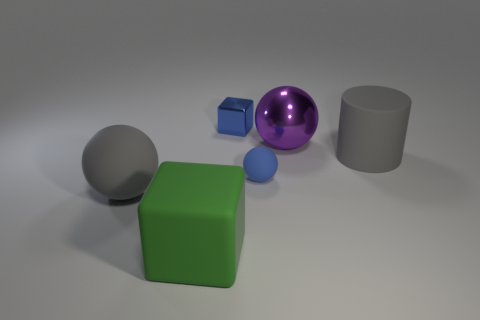What color is the small object that is made of the same material as the big green object?
Provide a short and direct response. Blue. Are there any other things that have the same size as the rubber cube?
Offer a very short reply. Yes. There is a object right of the big purple shiny thing; does it have the same color as the large ball that is behind the big gray cylinder?
Provide a short and direct response. No. Is the number of blue metallic blocks left of the big green block greater than the number of large purple balls to the left of the tiny blue metallic cube?
Ensure brevity in your answer.  No. There is another tiny metallic object that is the same shape as the green object; what color is it?
Your response must be concise. Blue. Are there any other things that are the same shape as the tiny matte thing?
Offer a terse response. Yes. Do the blue rubber object and the large gray rubber thing in front of the small sphere have the same shape?
Your answer should be very brief. Yes. What number of other things are there of the same material as the big block
Ensure brevity in your answer.  3. Is the color of the small matte ball the same as the block behind the big gray ball?
Keep it short and to the point. Yes. There is a object left of the green cube; what is its material?
Your answer should be very brief. Rubber. 